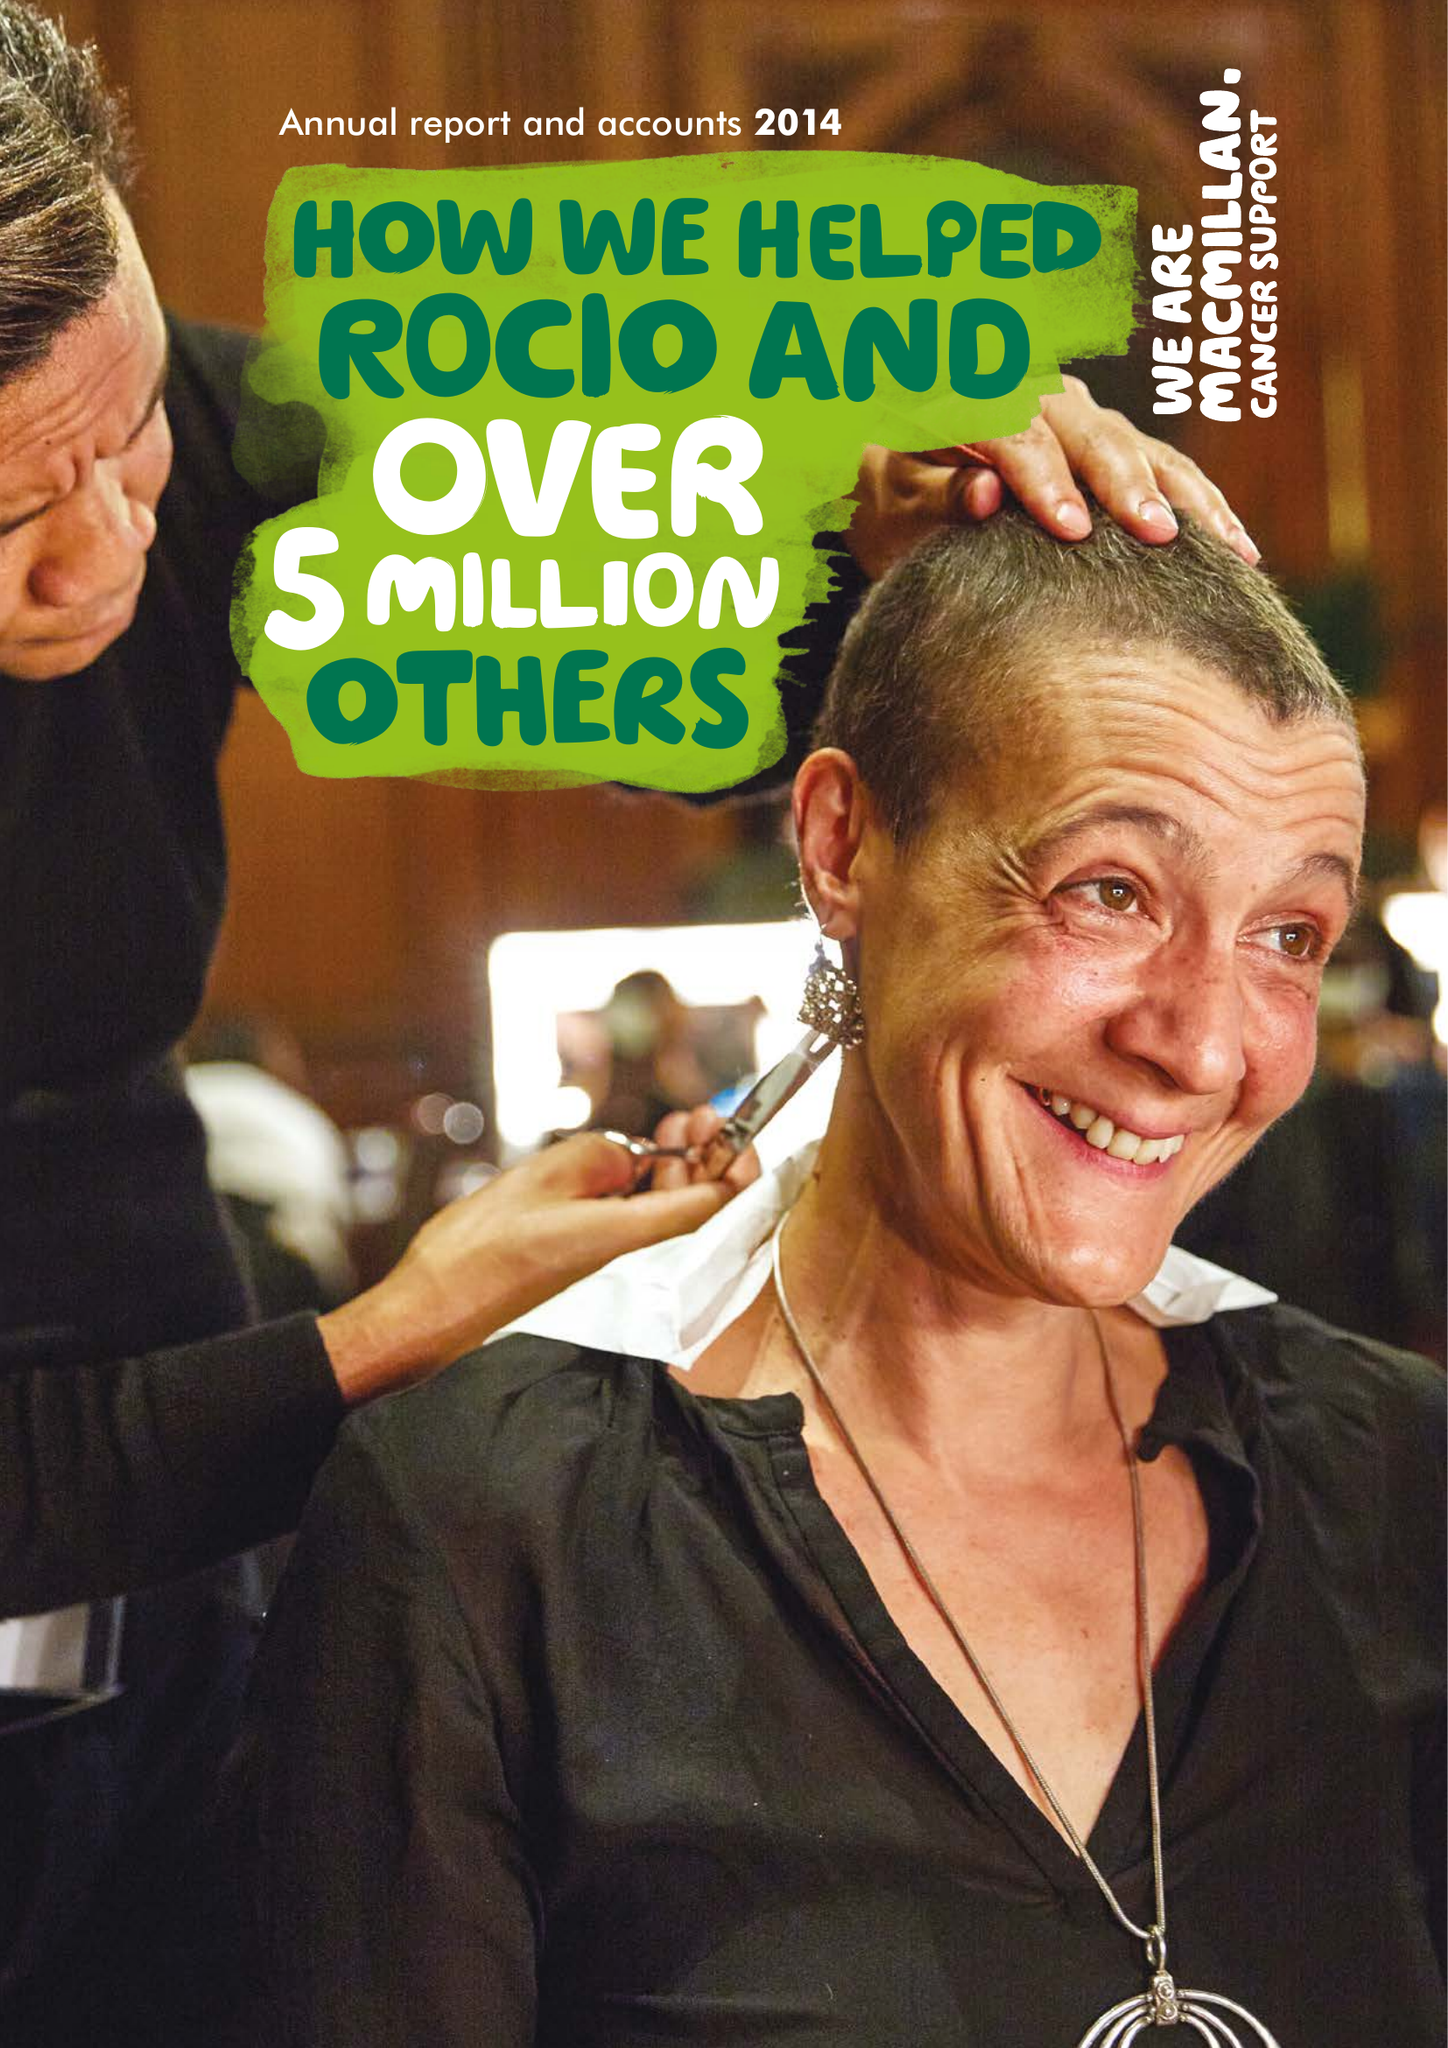What is the value for the income_annually_in_british_pounds?
Answer the question using a single word or phrase. 218430000.00 